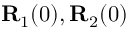Convert formula to latex. <formula><loc_0><loc_0><loc_500><loc_500>{ R } _ { 1 } ( 0 ) , { R } _ { 2 } ( 0 )</formula> 